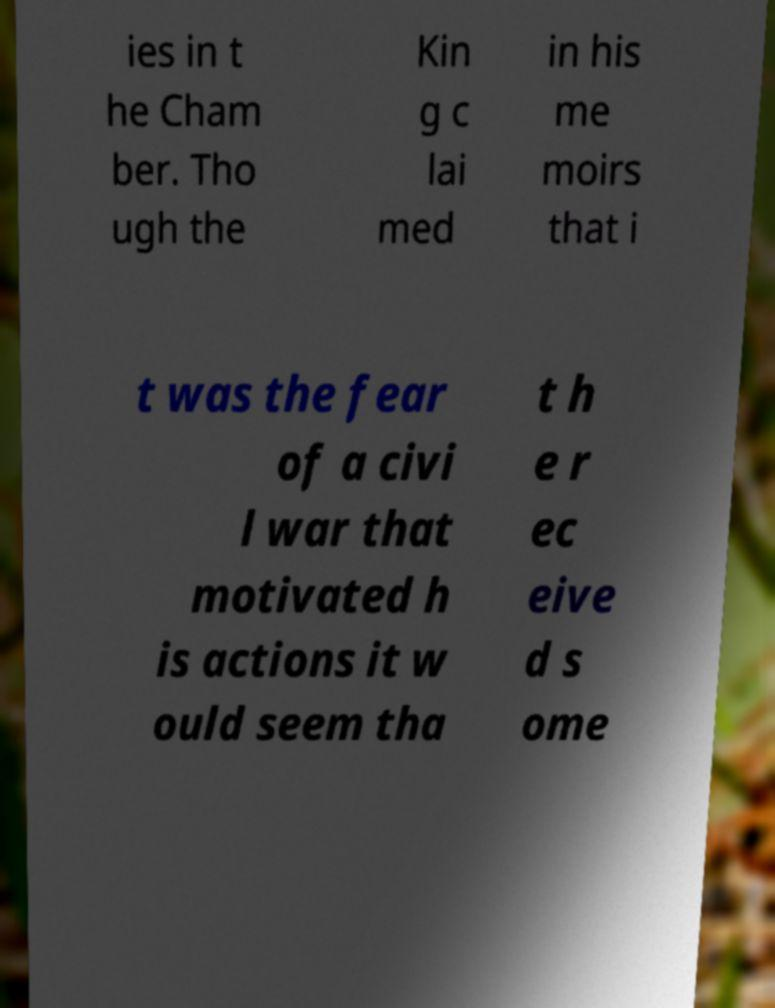Can you read and provide the text displayed in the image?This photo seems to have some interesting text. Can you extract and type it out for me? ies in t he Cham ber. Tho ugh the Kin g c lai med in his me moirs that i t was the fear of a civi l war that motivated h is actions it w ould seem tha t h e r ec eive d s ome 